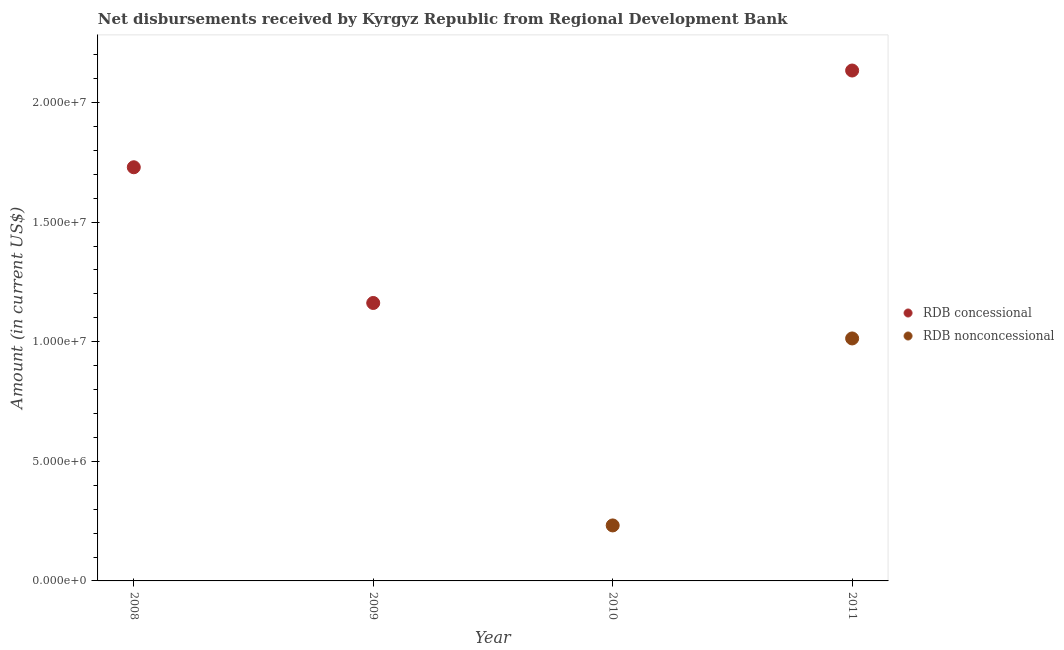Across all years, what is the maximum net concessional disbursements from rdb?
Give a very brief answer. 2.13e+07. What is the total net non concessional disbursements from rdb in the graph?
Offer a terse response. 1.25e+07. What is the difference between the net non concessional disbursements from rdb in 2010 and that in 2011?
Provide a short and direct response. -7.82e+06. What is the difference between the net non concessional disbursements from rdb in 2010 and the net concessional disbursements from rdb in 2008?
Make the answer very short. -1.50e+07. What is the average net non concessional disbursements from rdb per year?
Your response must be concise. 3.11e+06. In the year 2011, what is the difference between the net concessional disbursements from rdb and net non concessional disbursements from rdb?
Your answer should be compact. 1.12e+07. What is the ratio of the net non concessional disbursements from rdb in 2010 to that in 2011?
Your response must be concise. 0.23. What is the difference between the highest and the second highest net concessional disbursements from rdb?
Provide a succinct answer. 4.04e+06. What is the difference between the highest and the lowest net concessional disbursements from rdb?
Your answer should be compact. 2.13e+07. Is the sum of the net concessional disbursements from rdb in 2009 and 2011 greater than the maximum net non concessional disbursements from rdb across all years?
Make the answer very short. Yes. Is the net concessional disbursements from rdb strictly greater than the net non concessional disbursements from rdb over the years?
Keep it short and to the point. No. Is the net non concessional disbursements from rdb strictly less than the net concessional disbursements from rdb over the years?
Your answer should be very brief. No. How many dotlines are there?
Your response must be concise. 2. Are the values on the major ticks of Y-axis written in scientific E-notation?
Provide a succinct answer. Yes. Does the graph contain any zero values?
Your answer should be compact. Yes. Where does the legend appear in the graph?
Give a very brief answer. Center right. How many legend labels are there?
Give a very brief answer. 2. How are the legend labels stacked?
Provide a short and direct response. Vertical. What is the title of the graph?
Your response must be concise. Net disbursements received by Kyrgyz Republic from Regional Development Bank. What is the Amount (in current US$) of RDB concessional in 2008?
Give a very brief answer. 1.73e+07. What is the Amount (in current US$) in RDB nonconcessional in 2008?
Make the answer very short. 0. What is the Amount (in current US$) of RDB concessional in 2009?
Give a very brief answer. 1.16e+07. What is the Amount (in current US$) in RDB concessional in 2010?
Offer a very short reply. 0. What is the Amount (in current US$) of RDB nonconcessional in 2010?
Provide a succinct answer. 2.32e+06. What is the Amount (in current US$) of RDB concessional in 2011?
Your response must be concise. 2.13e+07. What is the Amount (in current US$) in RDB nonconcessional in 2011?
Your answer should be very brief. 1.01e+07. Across all years, what is the maximum Amount (in current US$) in RDB concessional?
Keep it short and to the point. 2.13e+07. Across all years, what is the maximum Amount (in current US$) in RDB nonconcessional?
Keep it short and to the point. 1.01e+07. Across all years, what is the minimum Amount (in current US$) of RDB concessional?
Provide a succinct answer. 0. Across all years, what is the minimum Amount (in current US$) in RDB nonconcessional?
Provide a short and direct response. 0. What is the total Amount (in current US$) in RDB concessional in the graph?
Make the answer very short. 5.03e+07. What is the total Amount (in current US$) in RDB nonconcessional in the graph?
Give a very brief answer. 1.25e+07. What is the difference between the Amount (in current US$) in RDB concessional in 2008 and that in 2009?
Keep it short and to the point. 5.67e+06. What is the difference between the Amount (in current US$) in RDB concessional in 2008 and that in 2011?
Your response must be concise. -4.04e+06. What is the difference between the Amount (in current US$) in RDB concessional in 2009 and that in 2011?
Your answer should be very brief. -9.72e+06. What is the difference between the Amount (in current US$) of RDB nonconcessional in 2010 and that in 2011?
Your response must be concise. -7.82e+06. What is the difference between the Amount (in current US$) in RDB concessional in 2008 and the Amount (in current US$) in RDB nonconcessional in 2010?
Give a very brief answer. 1.50e+07. What is the difference between the Amount (in current US$) of RDB concessional in 2008 and the Amount (in current US$) of RDB nonconcessional in 2011?
Offer a very short reply. 7.16e+06. What is the difference between the Amount (in current US$) in RDB concessional in 2009 and the Amount (in current US$) in RDB nonconcessional in 2010?
Provide a succinct answer. 9.30e+06. What is the difference between the Amount (in current US$) in RDB concessional in 2009 and the Amount (in current US$) in RDB nonconcessional in 2011?
Ensure brevity in your answer.  1.48e+06. What is the average Amount (in current US$) of RDB concessional per year?
Your answer should be compact. 1.26e+07. What is the average Amount (in current US$) of RDB nonconcessional per year?
Your response must be concise. 3.11e+06. In the year 2011, what is the difference between the Amount (in current US$) of RDB concessional and Amount (in current US$) of RDB nonconcessional?
Offer a terse response. 1.12e+07. What is the ratio of the Amount (in current US$) of RDB concessional in 2008 to that in 2009?
Make the answer very short. 1.49. What is the ratio of the Amount (in current US$) in RDB concessional in 2008 to that in 2011?
Make the answer very short. 0.81. What is the ratio of the Amount (in current US$) in RDB concessional in 2009 to that in 2011?
Your answer should be very brief. 0.54. What is the ratio of the Amount (in current US$) of RDB nonconcessional in 2010 to that in 2011?
Offer a terse response. 0.23. What is the difference between the highest and the second highest Amount (in current US$) in RDB concessional?
Ensure brevity in your answer.  4.04e+06. What is the difference between the highest and the lowest Amount (in current US$) of RDB concessional?
Offer a terse response. 2.13e+07. What is the difference between the highest and the lowest Amount (in current US$) in RDB nonconcessional?
Keep it short and to the point. 1.01e+07. 